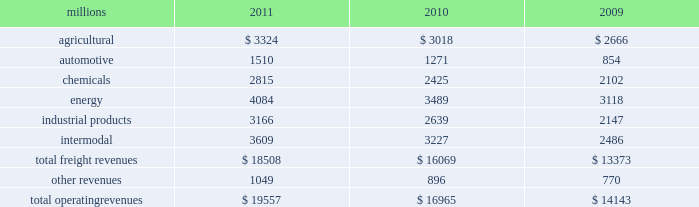Notes to the consolidated financial statements union pacific corporation and subsidiary companies for purposes of this report , unless the context otherwise requires , all references herein to the 201ccorporation 201d , 201cupc 201d , 201cwe 201d , 201cus 201d , and 201cour 201d mean union pacific corporation and its subsidiaries , including union pacific railroad company , which will be separately referred to herein as 201cuprr 201d or the 201crailroad 201d .
Nature of operations operations and segmentation 2013 we are a class i railroad that operates in the u.s .
Our network includes 31898 route miles , linking pacific coast and gulf coast ports with the midwest and eastern u.s .
Gateways and providing several corridors to key mexican gateways .
We own 26027 miles and operate on the remainder pursuant to trackage rights or leases .
We serve the western two-thirds of the country and maintain coordinated schedules with other rail carriers for the handling of freight to and from the atlantic coast , the pacific coast , the southeast , the southwest , canada , and mexico .
Export and import traffic is moved through gulf coast and pacific coast ports and across the mexican and canadian borders .
The railroad , along with its subsidiaries and rail affiliates , is our one reportable operating segment .
Although revenue is analyzed by commodity group , we analyze the net financial results of the railroad as one segment due to the integrated nature of our rail network .
The table provides freight revenue by commodity group : millions 2011 2010 2009 .
Although our revenues are principally derived from customers domiciled in the u.s. , the ultimate points of origination or destination for some products transported by us are outside the u.s .
Basis of presentation 2013 the consolidated financial statements are presented in accordance with accounting principles generally accepted in the u.s .
( gaap ) as codified in the financial accounting standards board ( fasb ) accounting standards codification ( asc ) .
Certain prior year amounts have been disaggregated to provide more detail and conform to the current period financial statement presentation .
Significant accounting policies principles of consolidation 2013 the consolidated financial statements include the accounts of union pacific corporation and all of its subsidiaries .
Investments in affiliated companies ( 20% ( 20 % ) to 50% ( 50 % ) owned ) are accounted for using the equity method of accounting .
All intercompany transactions are eliminated .
We currently have no less than majority-owned investments that require consolidation under variable interest entity requirements .
Cash and cash equivalents 2013 cash equivalents consist of investments with original maturities of three months or less .
Accounts receivable 2013 accounts receivable includes receivables reduced by an allowance for doubtful accounts .
The allowance is based upon historical losses , credit worthiness of customers , and current economic conditions .
Receivables not expected to be collected in one year and the associated allowances are classified as other assets in our consolidated statements of financial position. .
Using a three year averageintermodal was what percent of total revenue? 
Computations: divide(table_sum(intermodal, none), table_sum(total freight revenues, none))
Answer: 0.19441. 